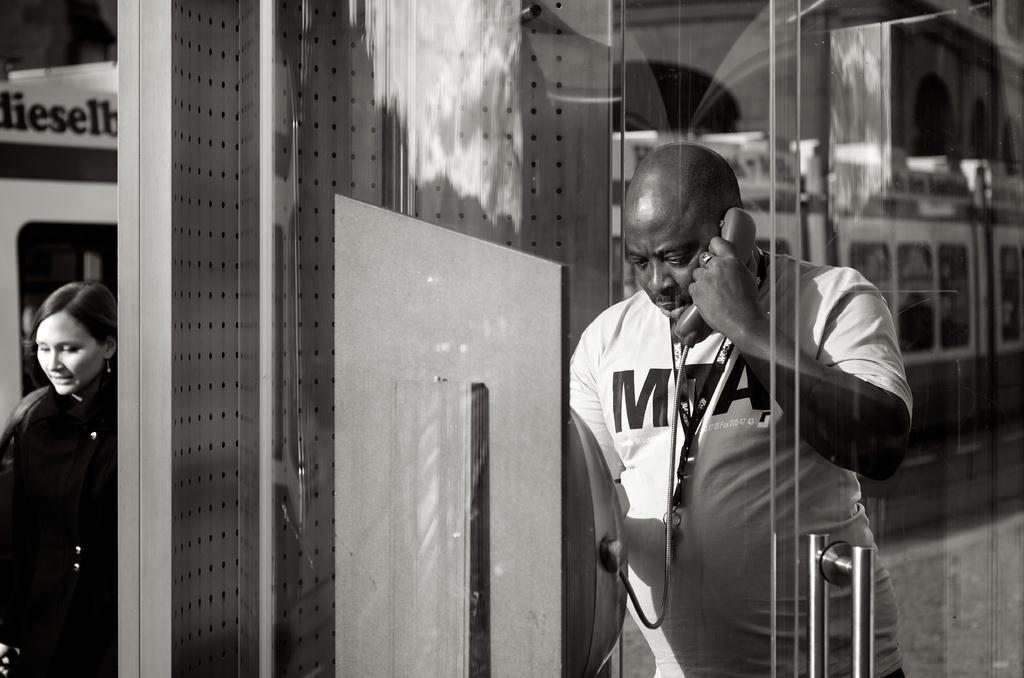Please provide a concise description of this image. In this image, on the right side, we can see a man standing and holding a telephone. On the left side, we can see a woman standing. In the background, we can see a train. 